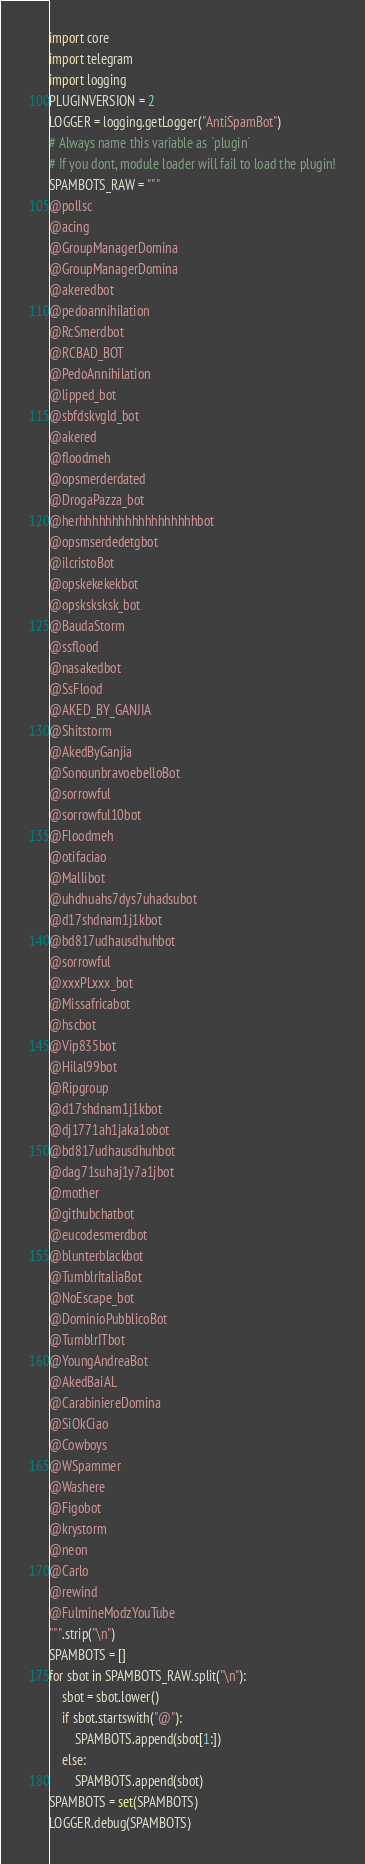<code> <loc_0><loc_0><loc_500><loc_500><_Python_>import core
import telegram
import logging
PLUGINVERSION = 2
LOGGER = logging.getLogger("AntiSpamBot")
# Always name this variable as `plugin`
# If you dont, module loader will fail to load the plugin!
SPAMBOTS_RAW = """
@pollsc
@acing
@GroupManagerDomina
@GroupManagerDomina
@akeredbot
@pedoannihilation
@RcSmerdbot
@RCBAD_BOT
@PedoAnnihilation
@lipped_bot
@sbfdskvgld_bot
@akered
@floodmeh
@opsmerderdated
@DrogaPazza_bot
@herhhhhhhhhhhhhhhhhhhbot
@opsmserdedetgbot
@ilcristoBot
@opskekekekbot
@opsksksksk_bot
@BaudaStorm
@ssflood
@nasakedbot
@SsFlood
@AKED_BY_GANJIA
@Shitstorm
@AkedByGanjia
@SonounbravoebelloBot
@sorrowful
@sorrowful10bot
@Floodmeh
@otifaciao
@Mallibot
@uhdhuahs7dys7uhadsubot
@d17shdnam1j1kbot
@bd817udhausdhuhbot
@sorrowful
@xxxPLxxx_bot
@Missafricabot
@hscbot
@Vip835bot
@Hilal99bot
@Ripgroup
@d17shdnam1j1kbot
@dj1771ah1jaka1obot
@bd817udhausdhuhbot
@dag71suhaj1y7a1jbot
@mother
@githubchatbot
@eucodesmerdbot
@blunterblackbot
@TumblrItaliaBot
@NoEscape_bot
@DominioPubblicoBot
@TumblrITbot
@YoungAndreaBot
@AkedBaiAL
@CarabiniereDomina
@SiOkCiao
@Cowboys
@WSpammer
@Washere
@Figobot
@krystorm
@neon
@Carlo
@rewind
@FulmineModzYouTube
""".strip("\n")
SPAMBOTS = []
for sbot in SPAMBOTS_RAW.split("\n"):
    sbot = sbot.lower()
    if sbot.startswith("@"):
        SPAMBOTS.append(sbot[1:])
    else:
        SPAMBOTS.append(sbot)
SPAMBOTS = set(SPAMBOTS)
LOGGER.debug(SPAMBOTS)</code> 